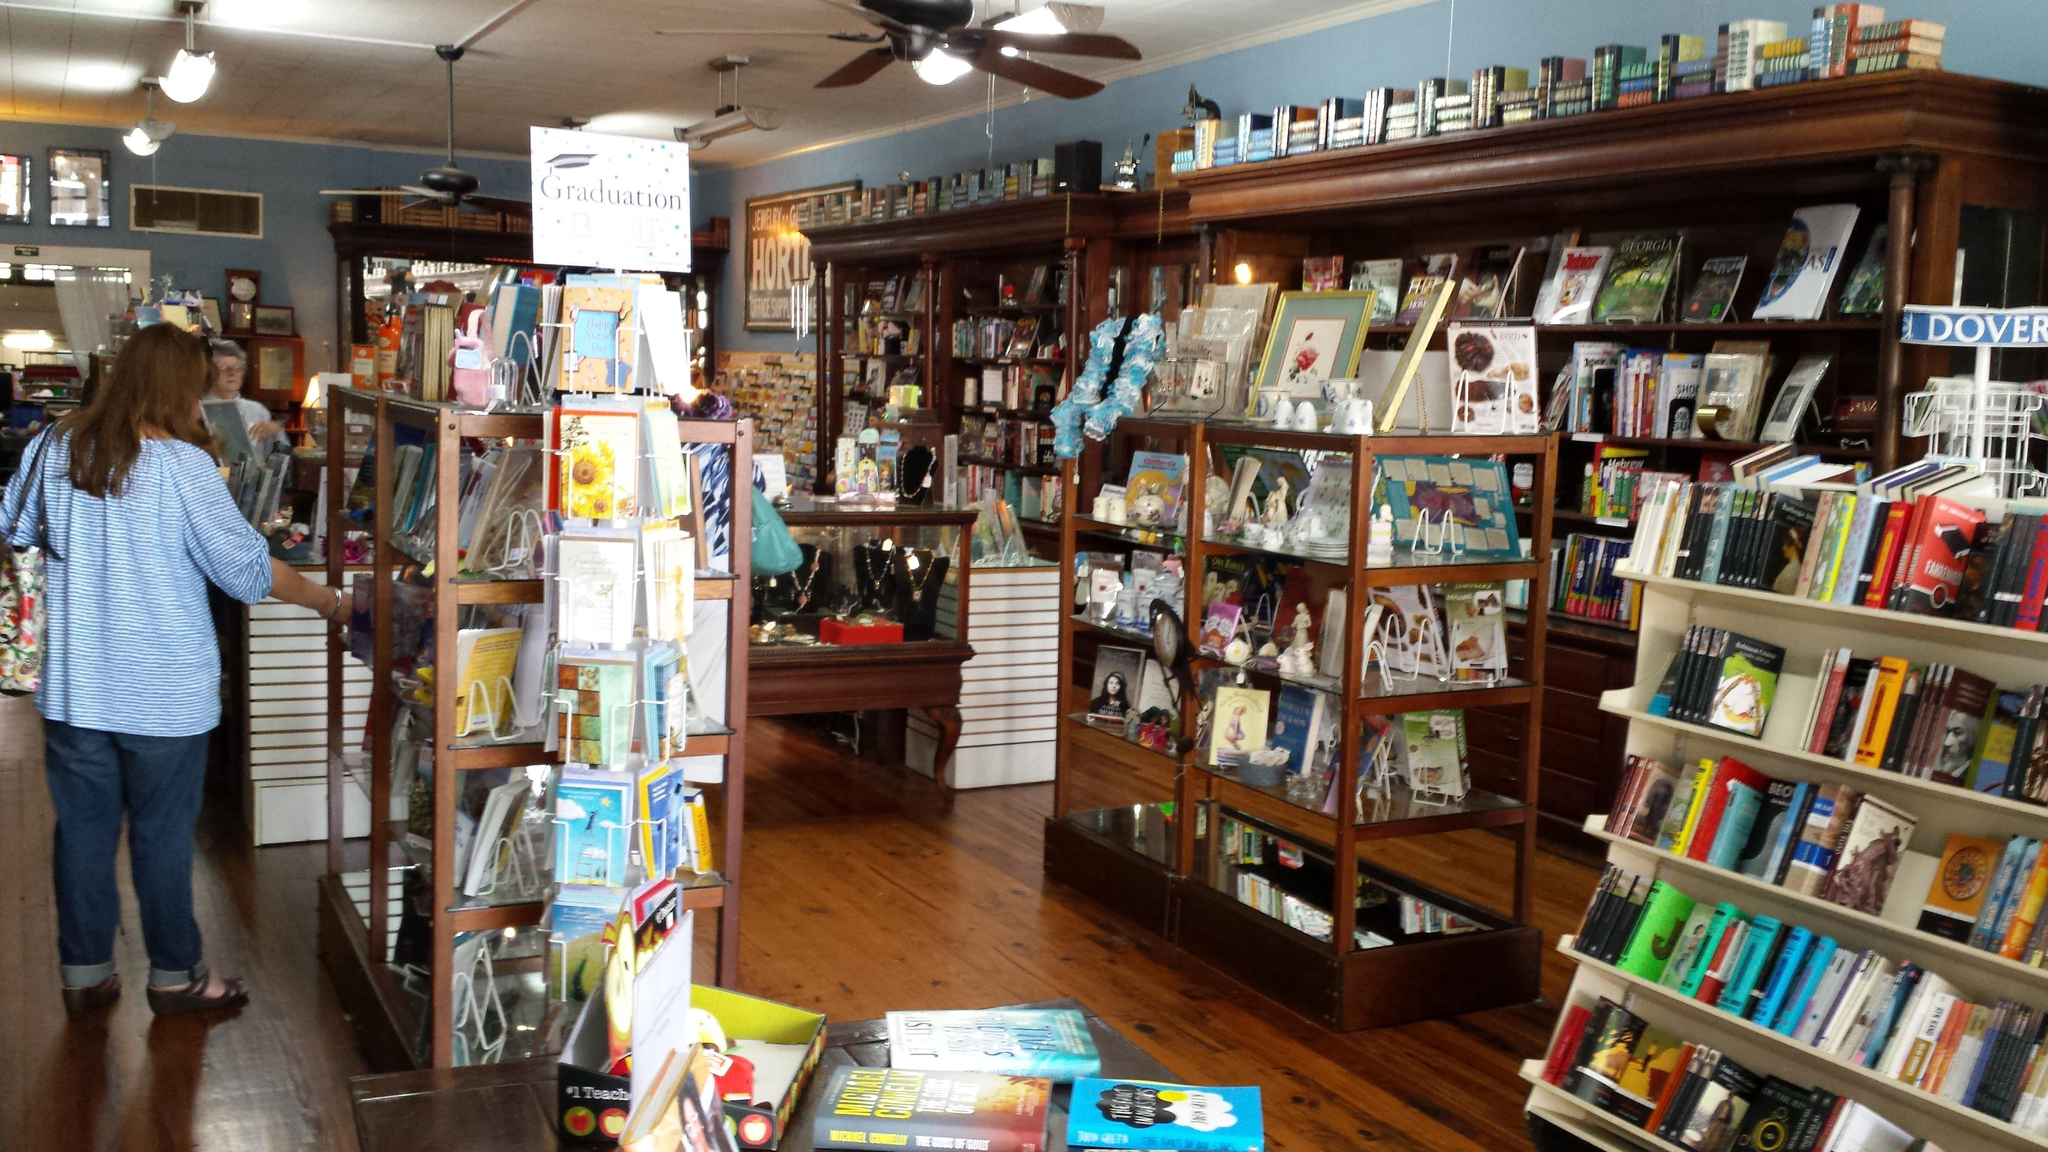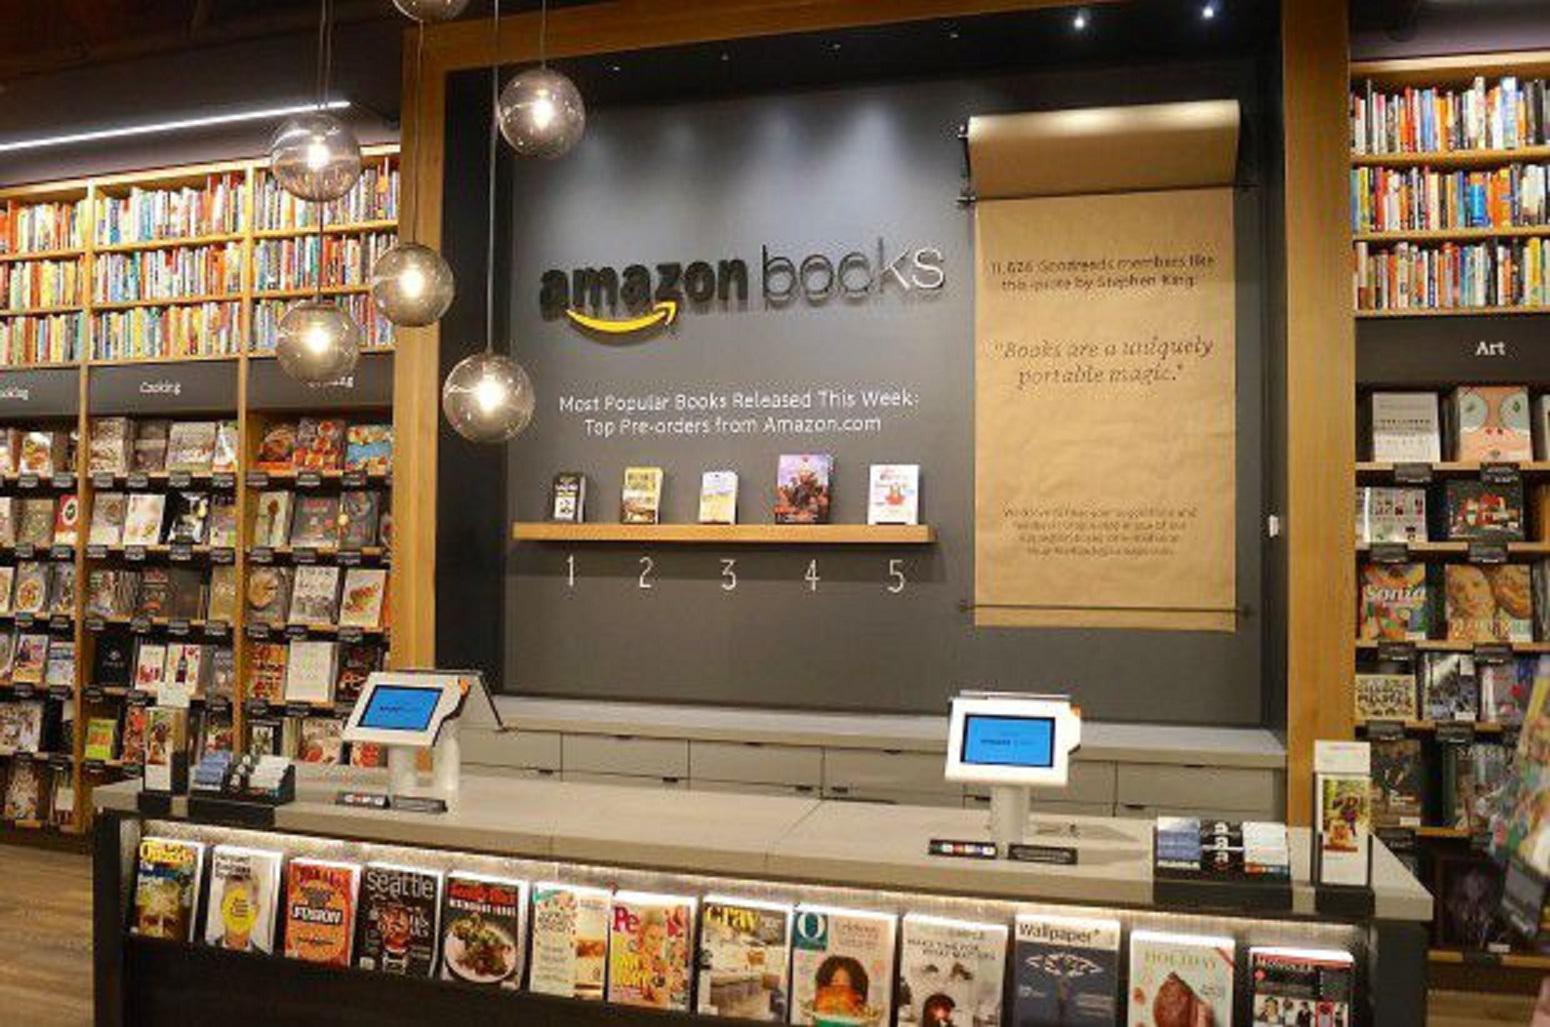The first image is the image on the left, the second image is the image on the right. Evaluate the accuracy of this statement regarding the images: "In at least one image there is a single long haired girl looking at book on a brown bookshelf.". Is it true? Answer yes or no. Yes. The first image is the image on the left, the second image is the image on the right. For the images shown, is this caption "There is one person in the bookstore looking at books in one of the images." true? Answer yes or no. Yes. 